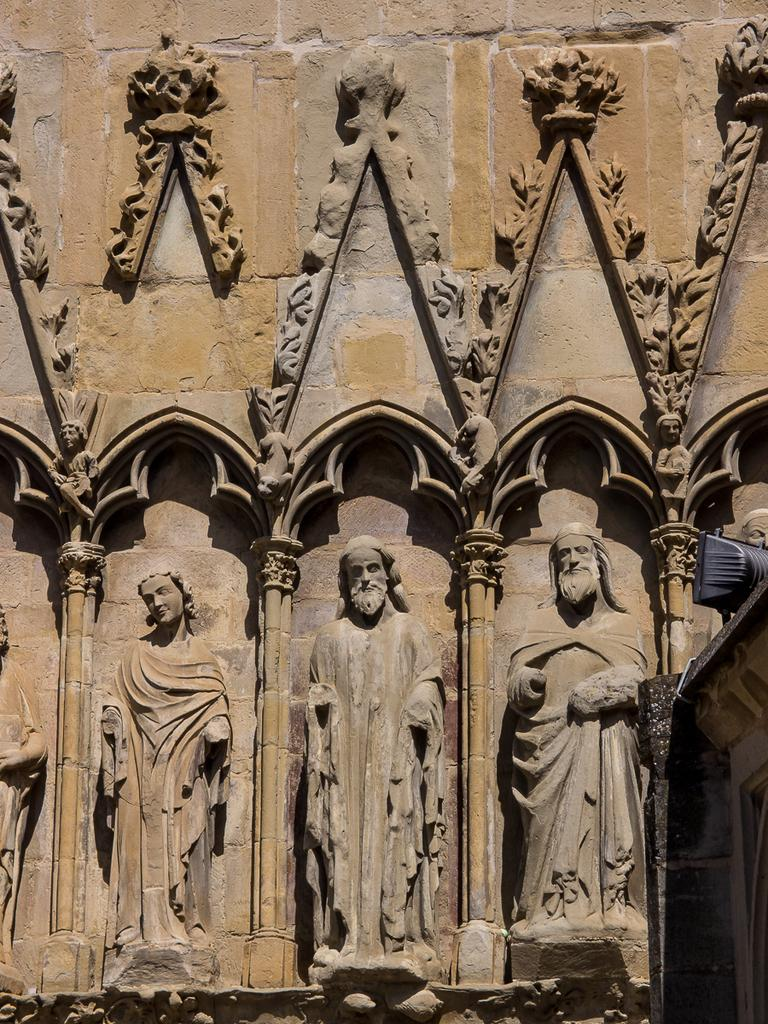What type of artifacts can be seen in the image? There are ancient sculptures in the image. What type of structure is present in the image? There is a building in the image. What is the rate of the class in the image? There is no class or rate present in the image; it features ancient sculptures and a building. What type of event is taking place in the image? There is no event present in the image; it features ancient sculptures and a building. 